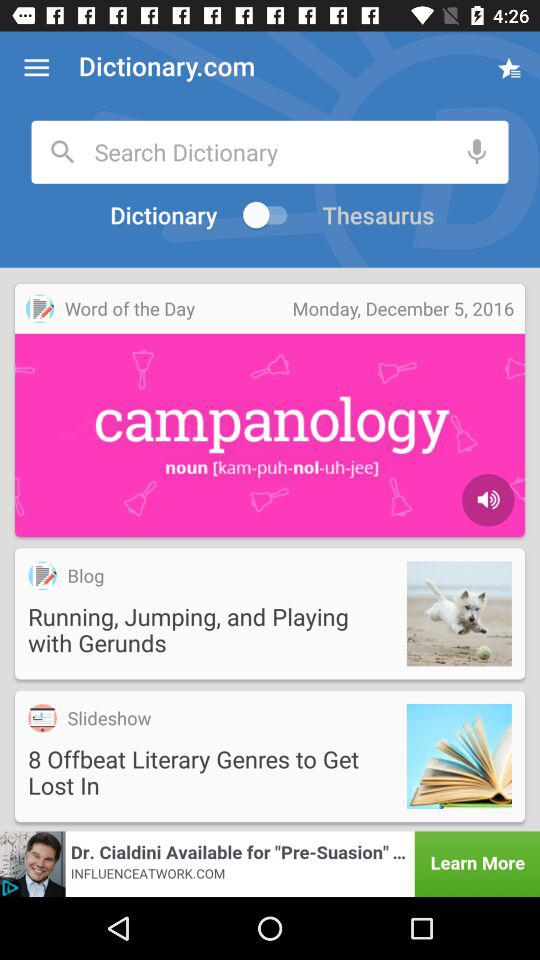What is the status of "Dictionary"? The status is "on". 